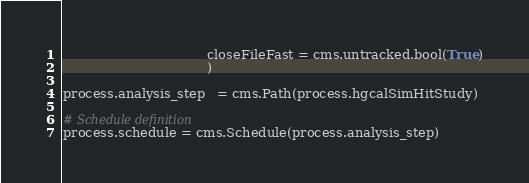<code> <loc_0><loc_0><loc_500><loc_500><_Python_>                                   closeFileFast = cms.untracked.bool(True)
                                   )

process.analysis_step   = cms.Path(process.hgcalSimHitStudy)

# Schedule definition
process.schedule = cms.Schedule(process.analysis_step)
</code> 